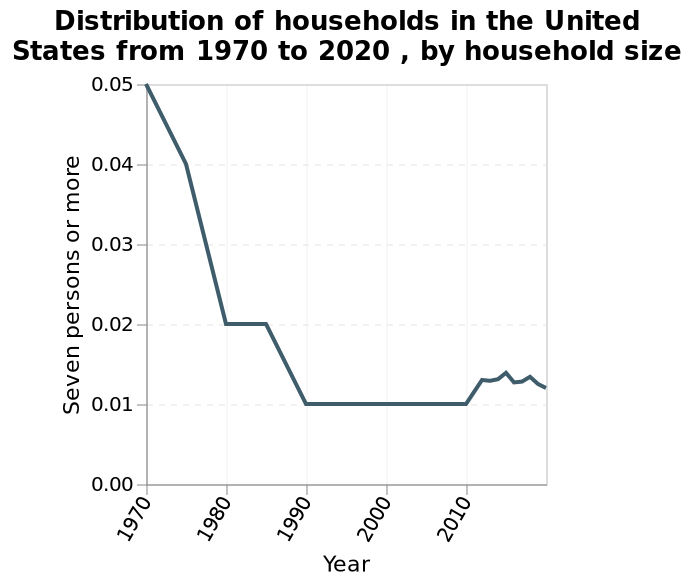<image>
What was the overall trend in the number of people in the household from 1970 to 2010? The overall trend in the number of people in the household was a sharp decline from 1970 to 1990, followed by a steady period until 2010, and a small increase thereafter. 